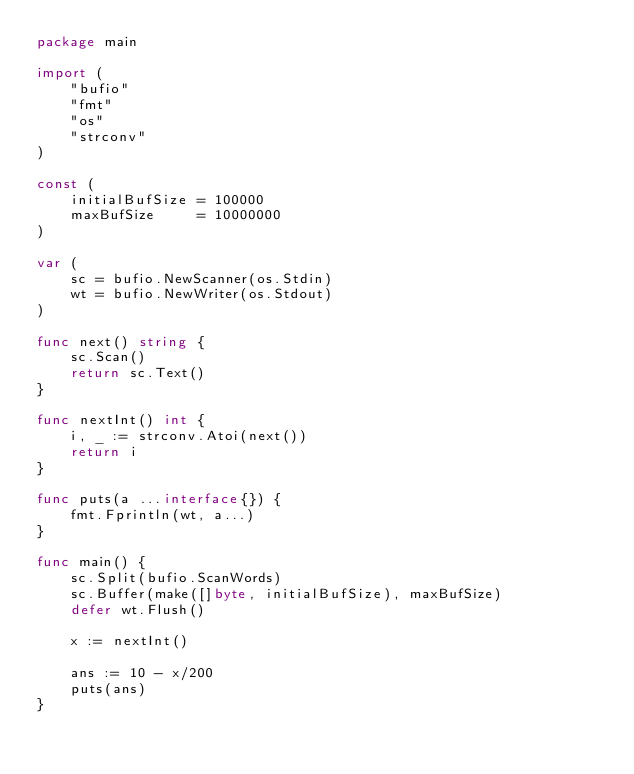Convert code to text. <code><loc_0><loc_0><loc_500><loc_500><_Go_>package main

import (
	"bufio"
	"fmt"
	"os"
	"strconv"
)

const (
	initialBufSize = 100000
	maxBufSize     = 10000000
)

var (
	sc = bufio.NewScanner(os.Stdin)
	wt = bufio.NewWriter(os.Stdout)
)

func next() string {
	sc.Scan()
	return sc.Text()
}

func nextInt() int {
	i, _ := strconv.Atoi(next())
	return i
}

func puts(a ...interface{}) {
	fmt.Fprintln(wt, a...)
}

func main() {
	sc.Split(bufio.ScanWords)
	sc.Buffer(make([]byte, initialBufSize), maxBufSize)
	defer wt.Flush()

	x := nextInt()

	ans := 10 - x/200
	puts(ans)
}
</code> 